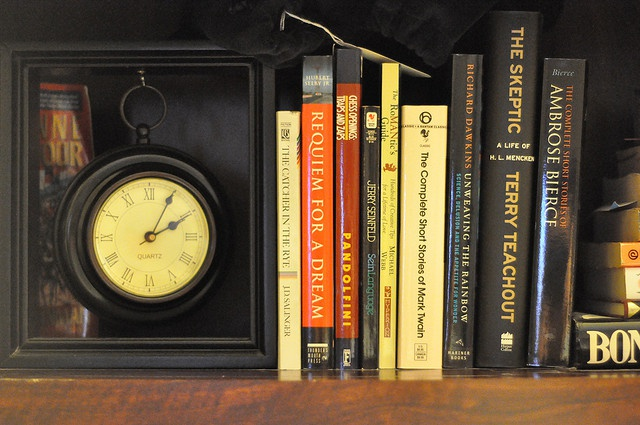Describe the objects in this image and their specific colors. I can see book in black and gray tones, clock in black, khaki, and gray tones, book in black, khaki, tan, and olive tones, book in black, red, gray, and khaki tones, and book in black and gray tones in this image. 